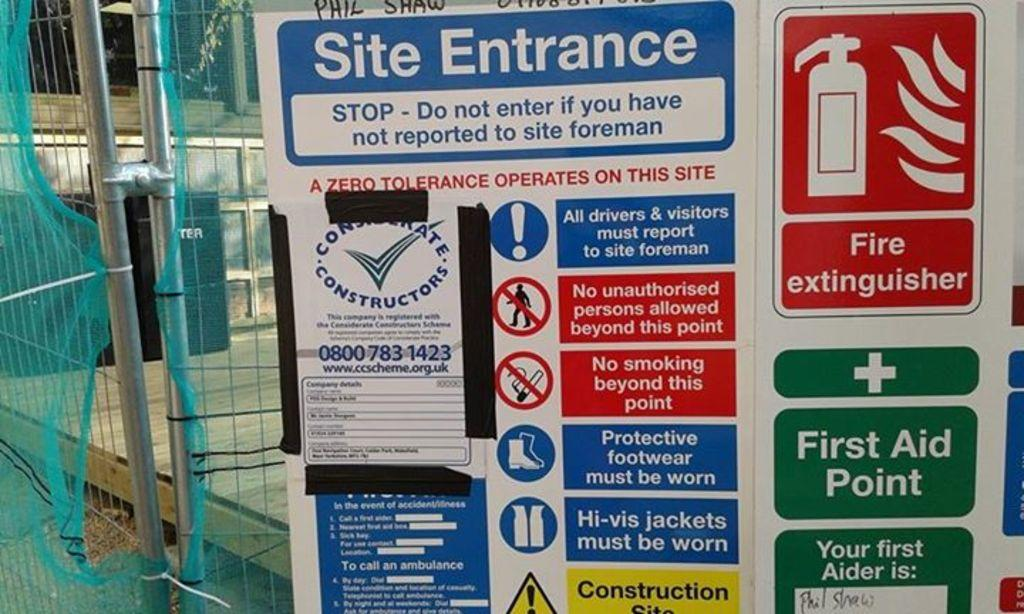<image>
Create a compact narrative representing the image presented. A grouped set of caution signs like side entrance and a sign for a first aid point. 